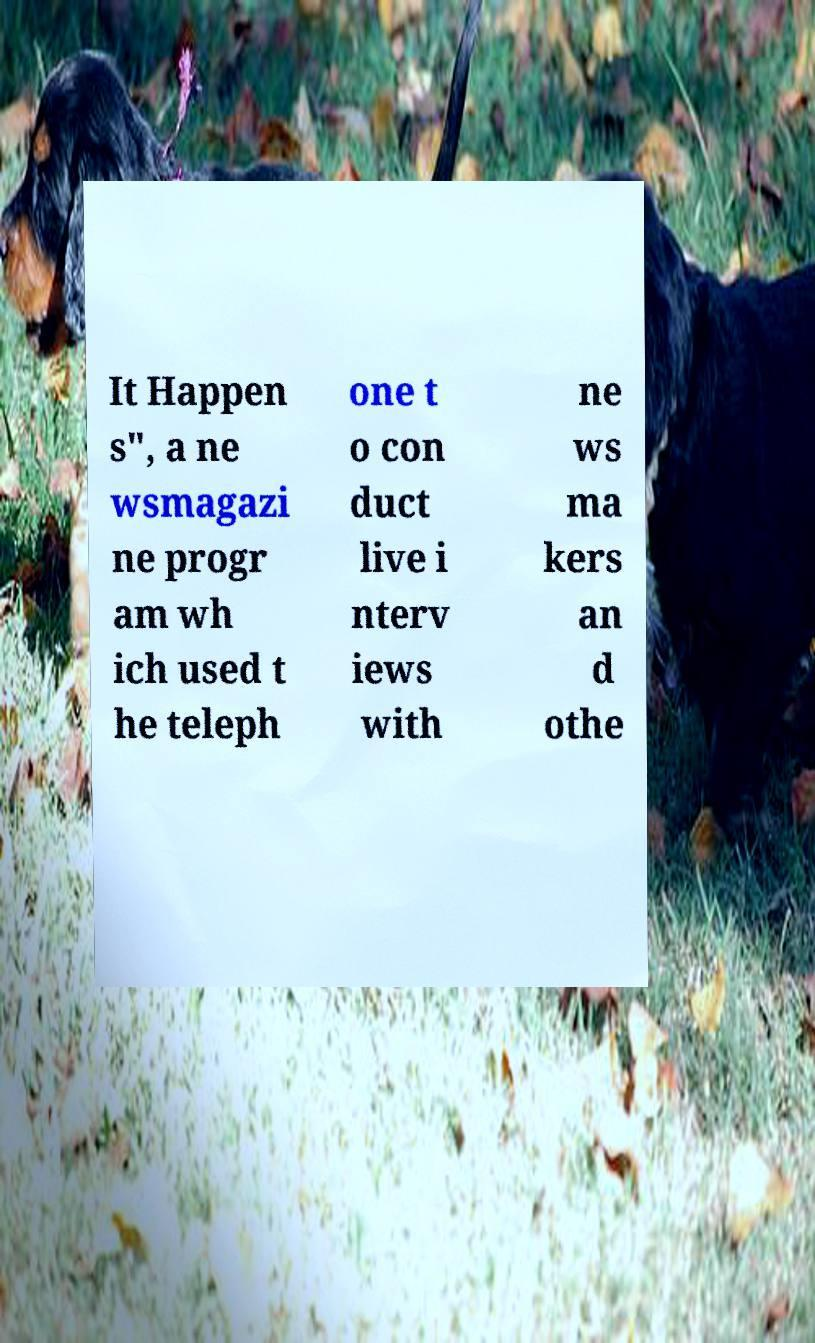Can you read and provide the text displayed in the image?This photo seems to have some interesting text. Can you extract and type it out for me? It Happen s", a ne wsmagazi ne progr am wh ich used t he teleph one t o con duct live i nterv iews with ne ws ma kers an d othe 